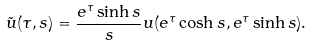Convert formula to latex. <formula><loc_0><loc_0><loc_500><loc_500>\tilde { u } ( \tau , s ) = \frac { e ^ { \tau } \sinh s } { s } u ( e ^ { \tau } \cosh s , e ^ { \tau } \sinh s ) .</formula> 